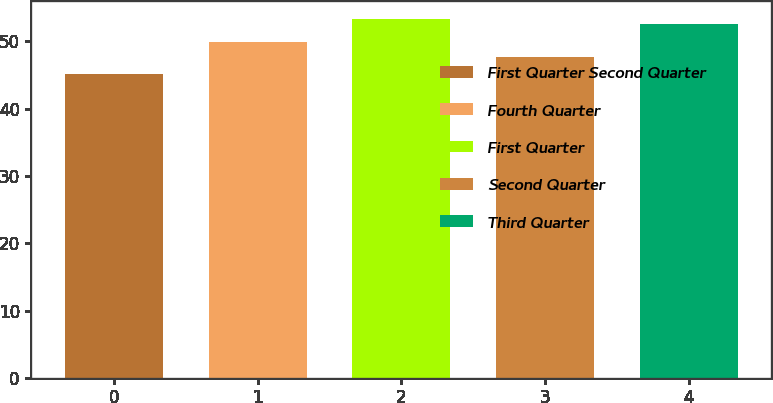Convert chart. <chart><loc_0><loc_0><loc_500><loc_500><bar_chart><fcel>First Quarter Second Quarter<fcel>Fourth Quarter<fcel>First Quarter<fcel>Second Quarter<fcel>Third Quarter<nl><fcel>45.1<fcel>49.9<fcel>53.31<fcel>47.7<fcel>52.55<nl></chart> 